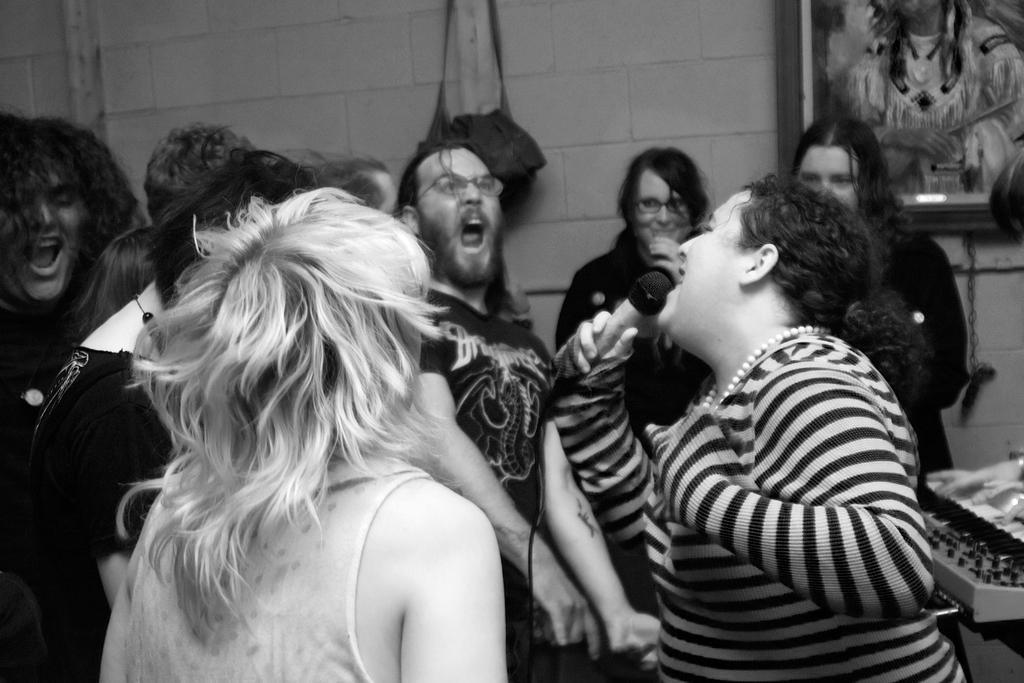Could you give a brief overview of what you see in this image? This is a black and white image. There is one woman holding a Mic and singing as we can see on the right of this image. There is a group of persons joined and enjoying in the middle of this image, and there is a wall in the background. There is one bag and a photo frame is attached to this wall. 